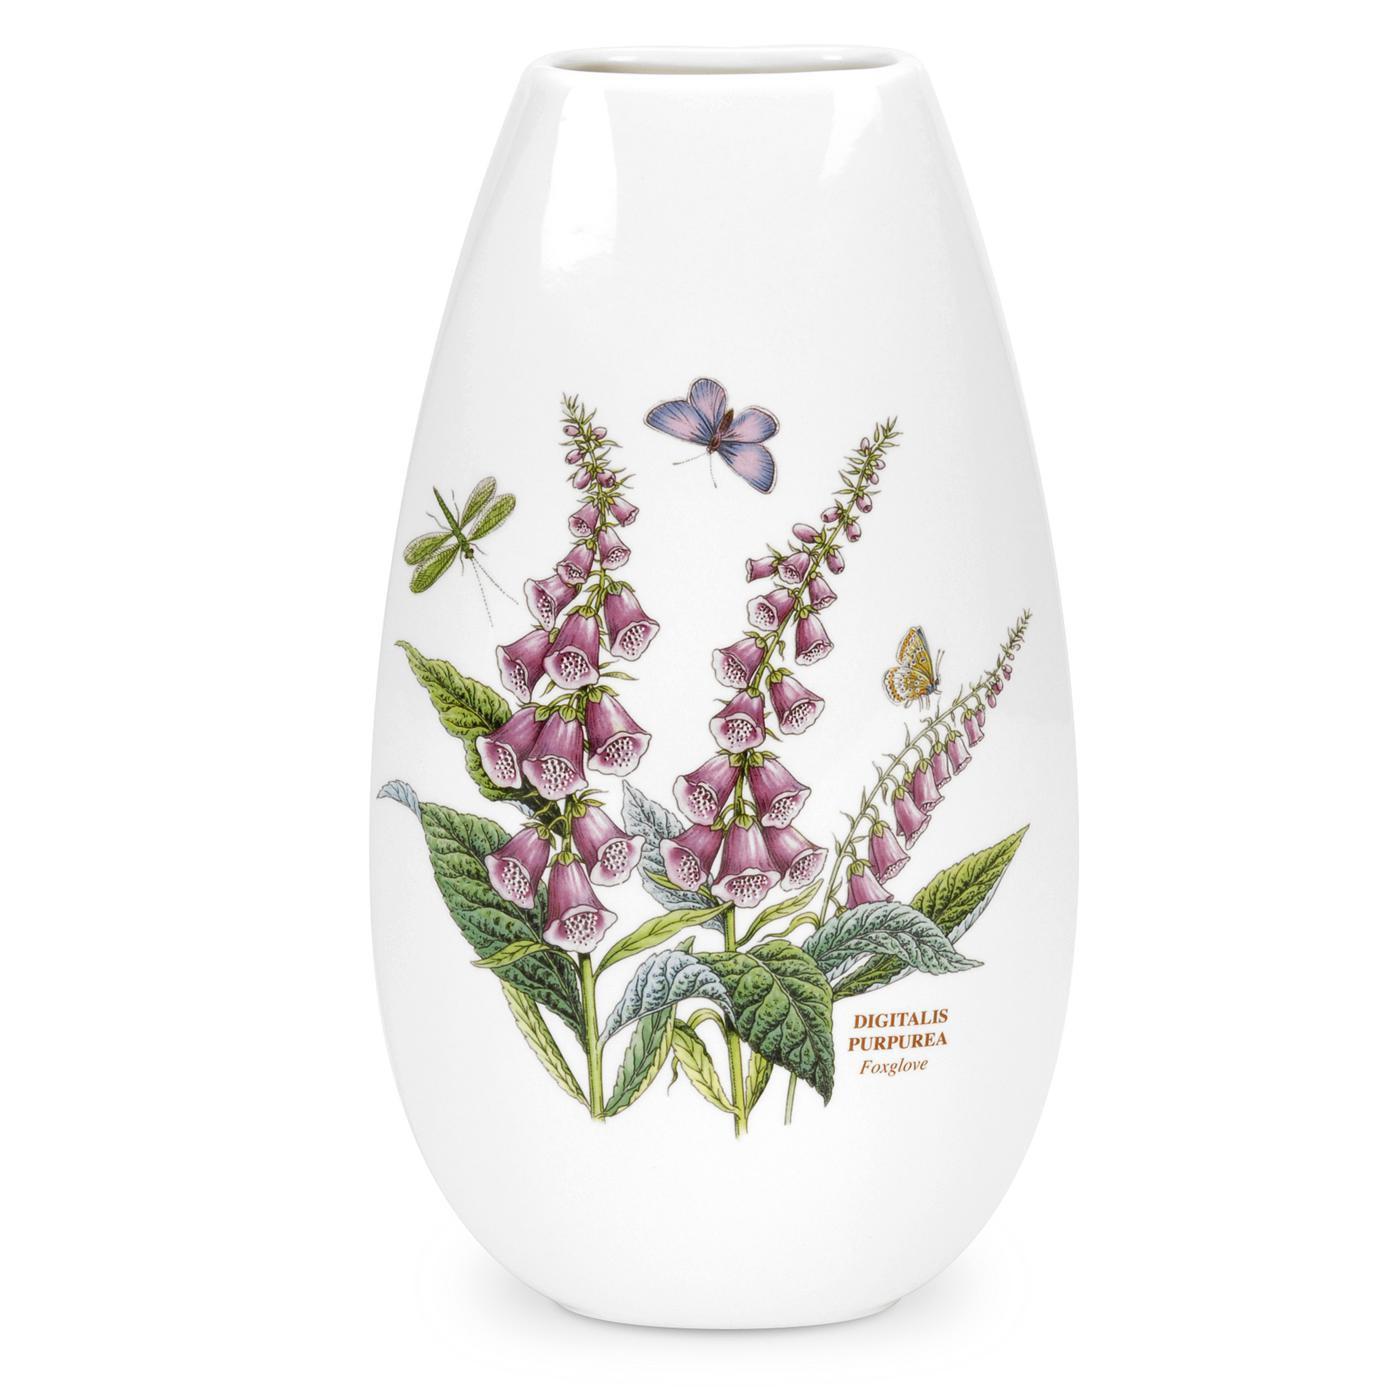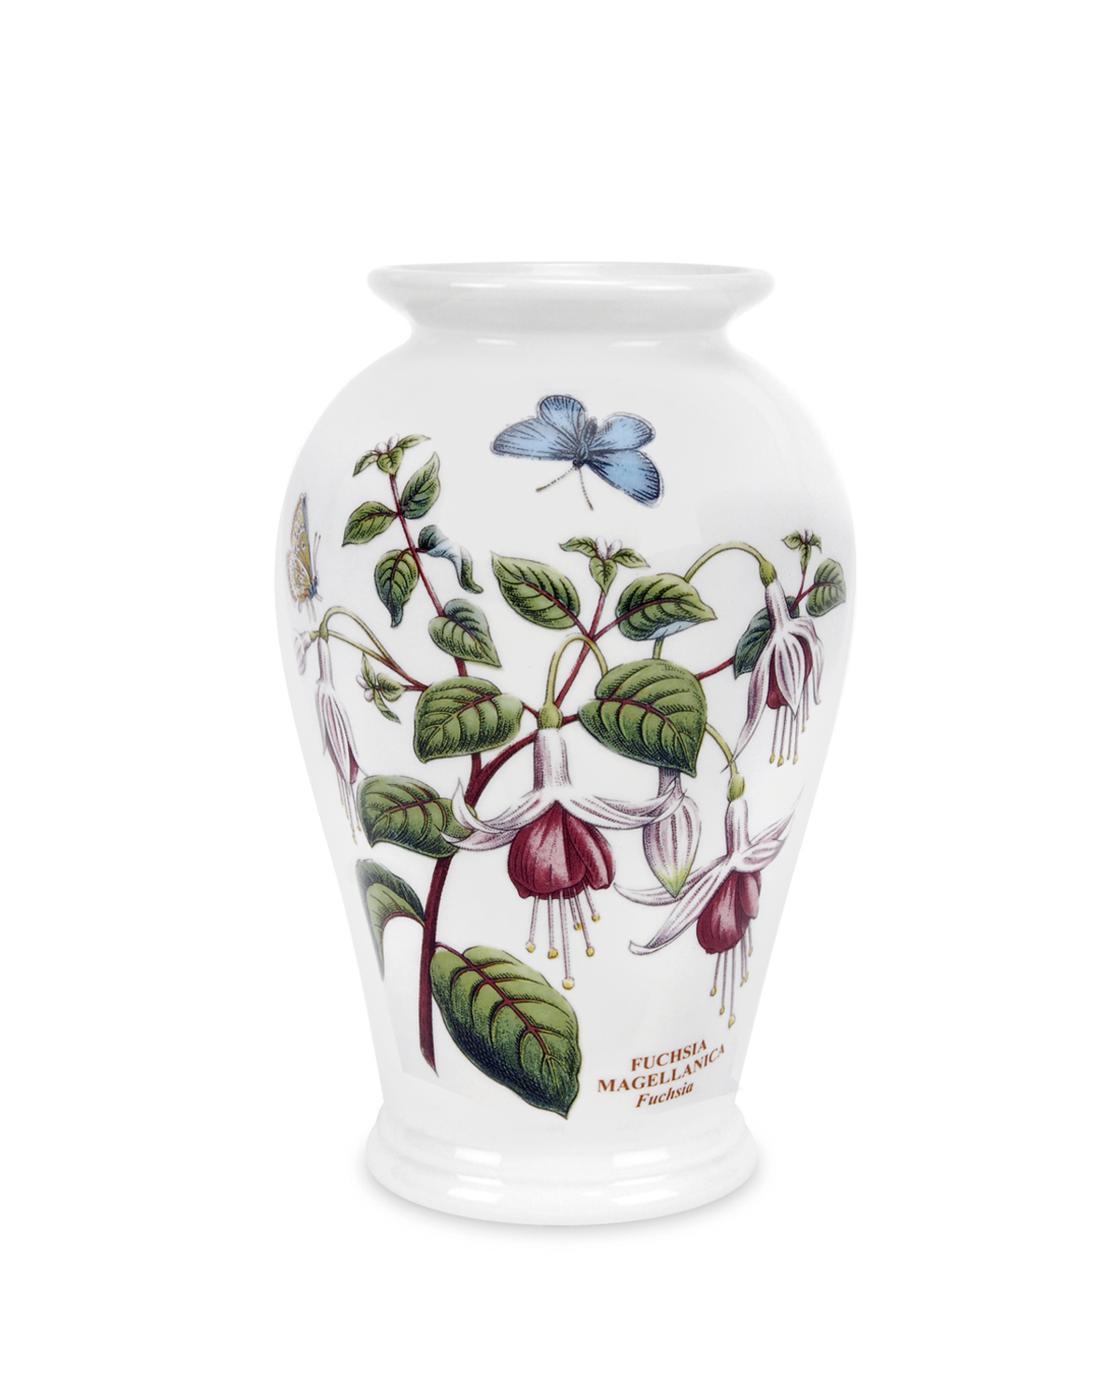The first image is the image on the left, the second image is the image on the right. Considering the images on both sides, is "One of the two vases is decorated with digitalis flowering plants and a purple butterfly, the other vase has a blue butterfly." valid? Answer yes or no. Yes. 